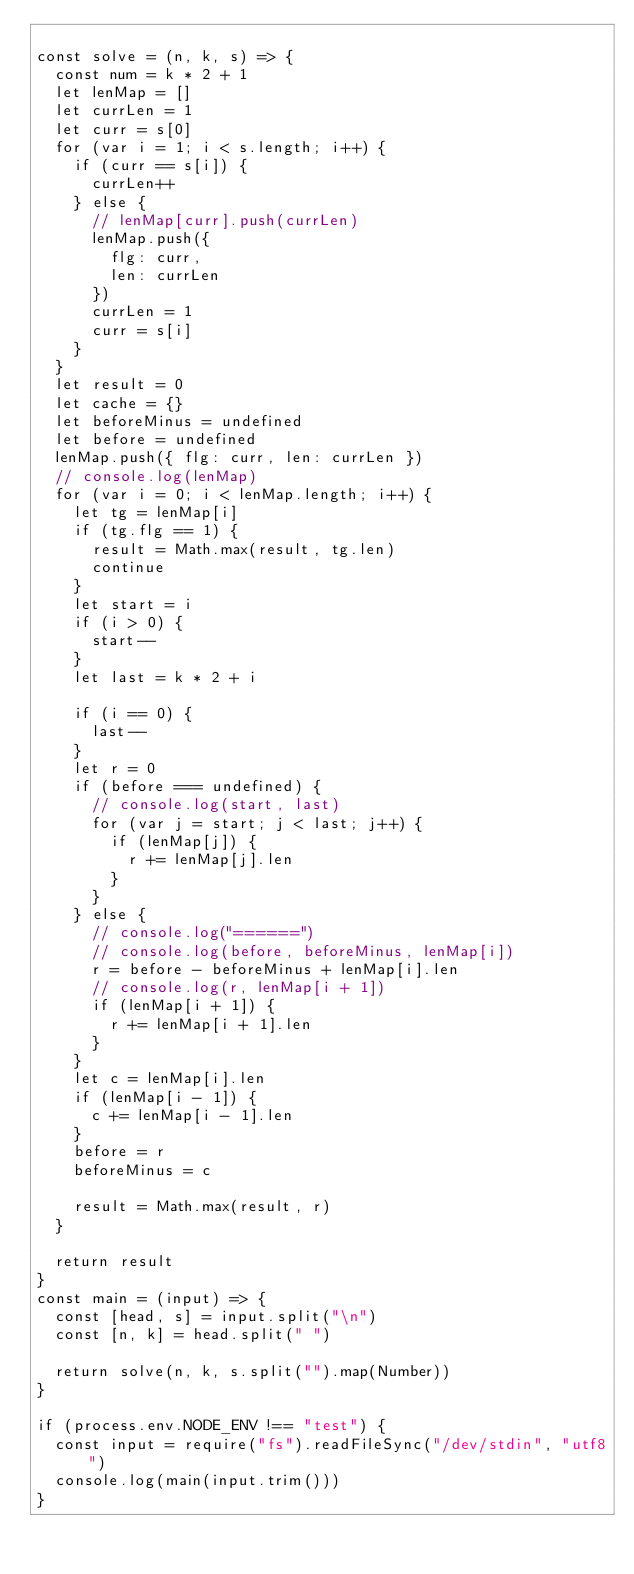Convert code to text. <code><loc_0><loc_0><loc_500><loc_500><_TypeScript_>
const solve = (n, k, s) => {
  const num = k * 2 + 1
  let lenMap = []
  let currLen = 1
  let curr = s[0]
  for (var i = 1; i < s.length; i++) {
    if (curr == s[i]) {
      currLen++
    } else {
      // lenMap[curr].push(currLen)
      lenMap.push({
        flg: curr,
        len: currLen
      })
      currLen = 1
      curr = s[i]
    }
  }
  let result = 0
  let cache = {}
  let beforeMinus = undefined
  let before = undefined
  lenMap.push({ flg: curr, len: currLen })
  // console.log(lenMap)
  for (var i = 0; i < lenMap.length; i++) {
    let tg = lenMap[i]
    if (tg.flg == 1) {
      result = Math.max(result, tg.len)
      continue
    }
    let start = i
    if (i > 0) {
      start--
    }
    let last = k * 2 + i

    if (i == 0) {
      last--
    }
    let r = 0
    if (before === undefined) {
      // console.log(start, last)
      for (var j = start; j < last; j++) {
        if (lenMap[j]) {
          r += lenMap[j].len
        }
      }
    } else {
      // console.log("======")
      // console.log(before, beforeMinus, lenMap[i])
      r = before - beforeMinus + lenMap[i].len
      // console.log(r, lenMap[i + 1])
      if (lenMap[i + 1]) {
        r += lenMap[i + 1].len
      }
    }
    let c = lenMap[i].len
    if (lenMap[i - 1]) {
      c += lenMap[i - 1].len
    }
    before = r
    beforeMinus = c

    result = Math.max(result, r)
  }

  return result
}
const main = (input) => {
  const [head, s] = input.split("\n")
  const [n, k] = head.split(" ")

  return solve(n, k, s.split("").map(Number))
}

if (process.env.NODE_ENV !== "test") {
  const input = require("fs").readFileSync("/dev/stdin", "utf8")
  console.log(main(input.trim()))
}</code> 